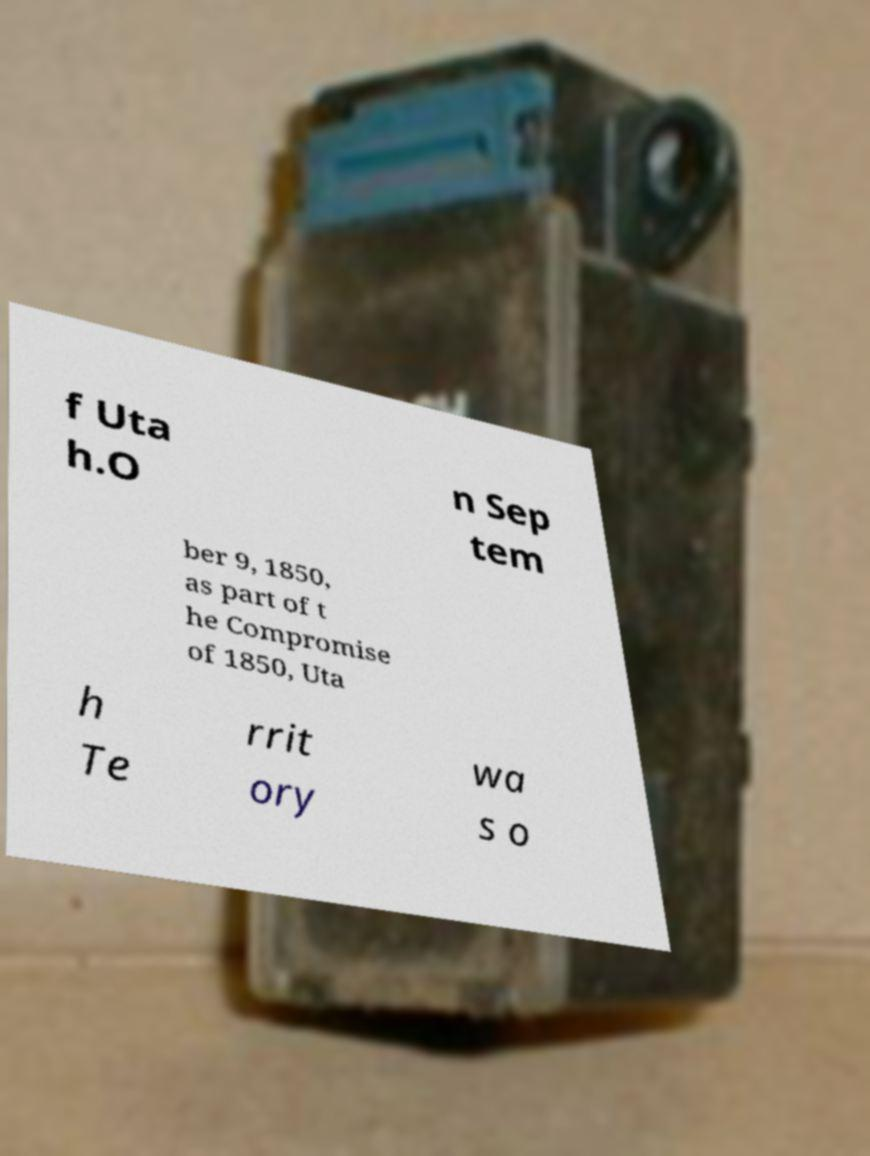Please read and relay the text visible in this image. What does it say? f Uta h.O n Sep tem ber 9, 1850, as part of t he Compromise of 1850, Uta h Te rrit ory wa s o 